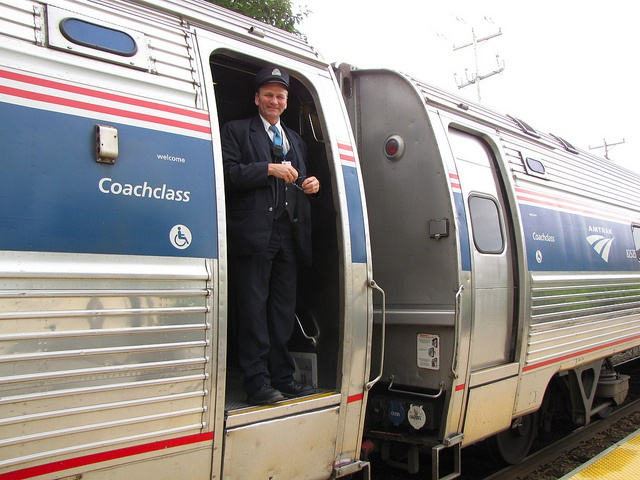Describe the objects in this image and their specific colors. I can see train in black, white, darkgray, and gray tones, people in white, black, gray, and brown tones, and tie in white, lightblue, gray, and blue tones in this image. 